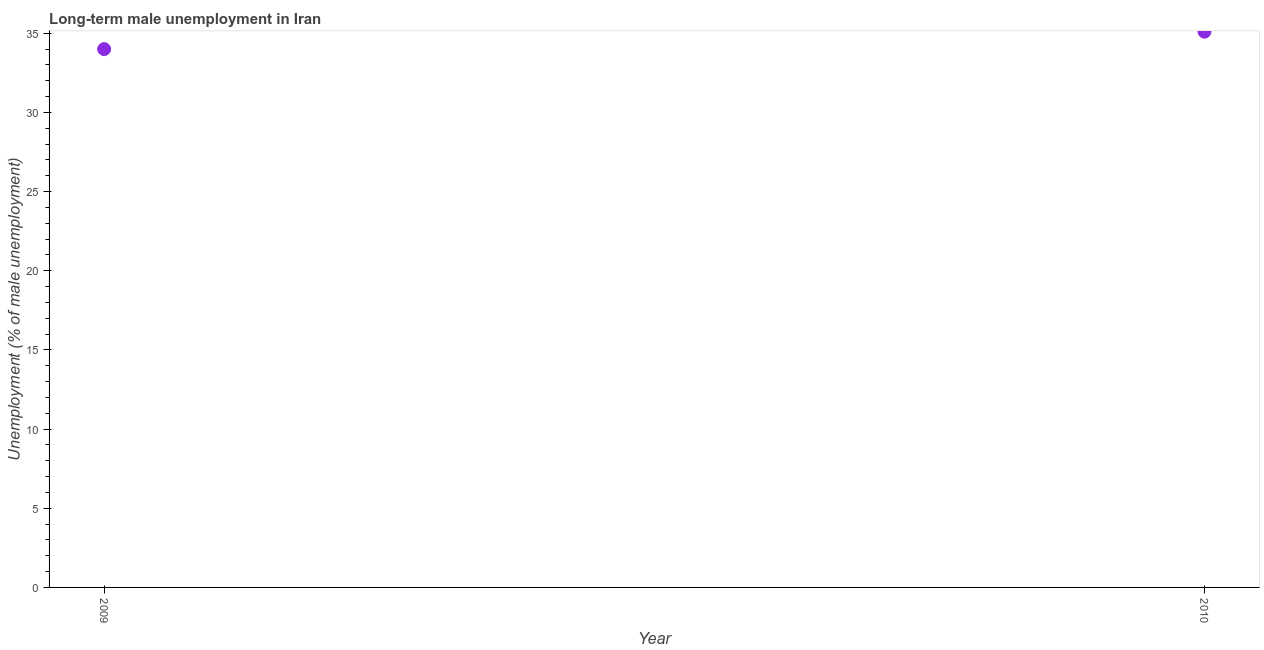What is the long-term male unemployment in 2010?
Offer a very short reply. 35.1. Across all years, what is the maximum long-term male unemployment?
Keep it short and to the point. 35.1. What is the sum of the long-term male unemployment?
Keep it short and to the point. 69.1. What is the difference between the long-term male unemployment in 2009 and 2010?
Make the answer very short. -1.1. What is the average long-term male unemployment per year?
Make the answer very short. 34.55. What is the median long-term male unemployment?
Make the answer very short. 34.55. Do a majority of the years between 2009 and 2010 (inclusive) have long-term male unemployment greater than 13 %?
Ensure brevity in your answer.  Yes. What is the ratio of the long-term male unemployment in 2009 to that in 2010?
Ensure brevity in your answer.  0.97. Does the long-term male unemployment monotonically increase over the years?
Your response must be concise. Yes. How many years are there in the graph?
Your response must be concise. 2. What is the difference between two consecutive major ticks on the Y-axis?
Keep it short and to the point. 5. Are the values on the major ticks of Y-axis written in scientific E-notation?
Your answer should be compact. No. Does the graph contain grids?
Your answer should be compact. No. What is the title of the graph?
Your answer should be very brief. Long-term male unemployment in Iran. What is the label or title of the Y-axis?
Provide a short and direct response. Unemployment (% of male unemployment). What is the Unemployment (% of male unemployment) in 2010?
Your answer should be very brief. 35.1. What is the ratio of the Unemployment (% of male unemployment) in 2009 to that in 2010?
Ensure brevity in your answer.  0.97. 